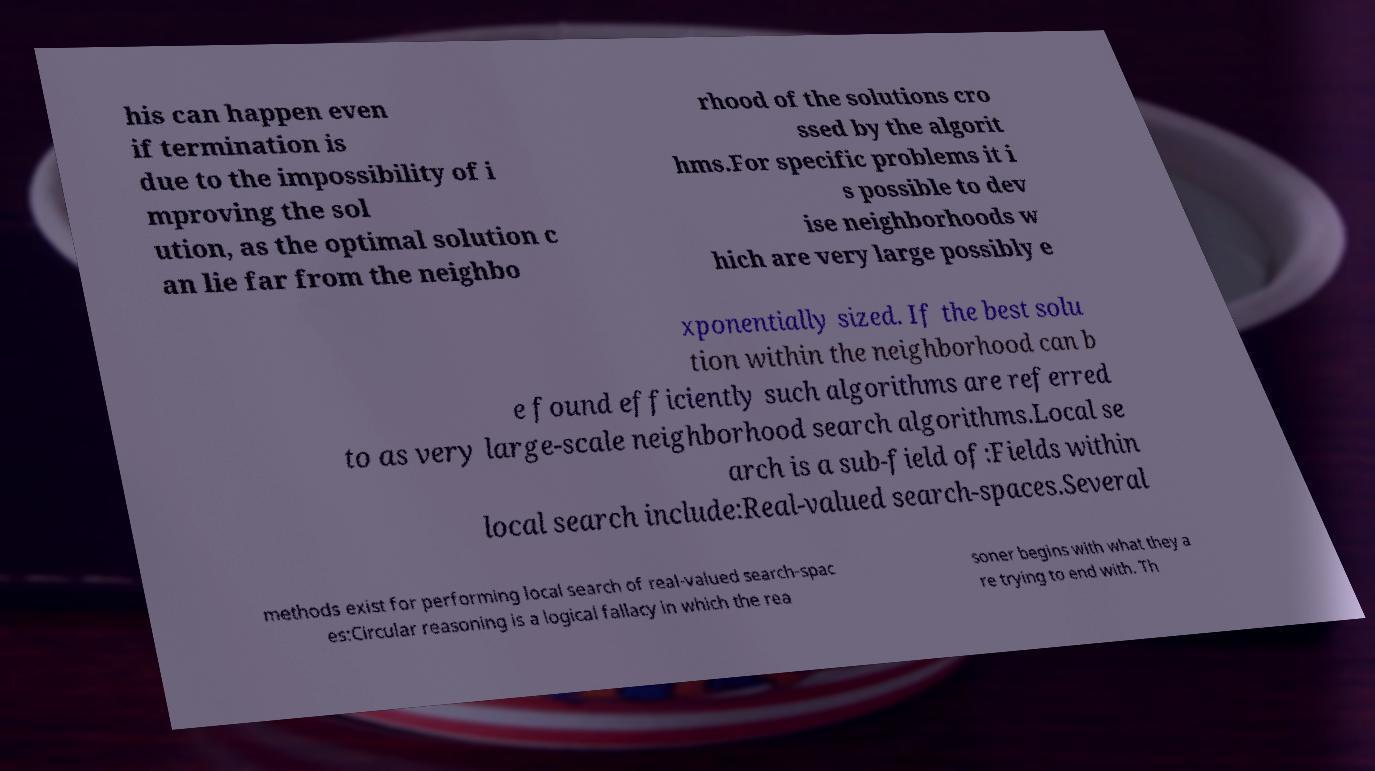Please identify and transcribe the text found in this image. his can happen even if termination is due to the impossibility of i mproving the sol ution, as the optimal solution c an lie far from the neighbo rhood of the solutions cro ssed by the algorit hms.For specific problems it i s possible to dev ise neighborhoods w hich are very large possibly e xponentially sized. If the best solu tion within the neighborhood can b e found efficiently such algorithms are referred to as very large-scale neighborhood search algorithms.Local se arch is a sub-field of:Fields within local search include:Real-valued search-spaces.Several methods exist for performing local search of real-valued search-spac es:Circular reasoning is a logical fallacy in which the rea soner begins with what they a re trying to end with. Th 